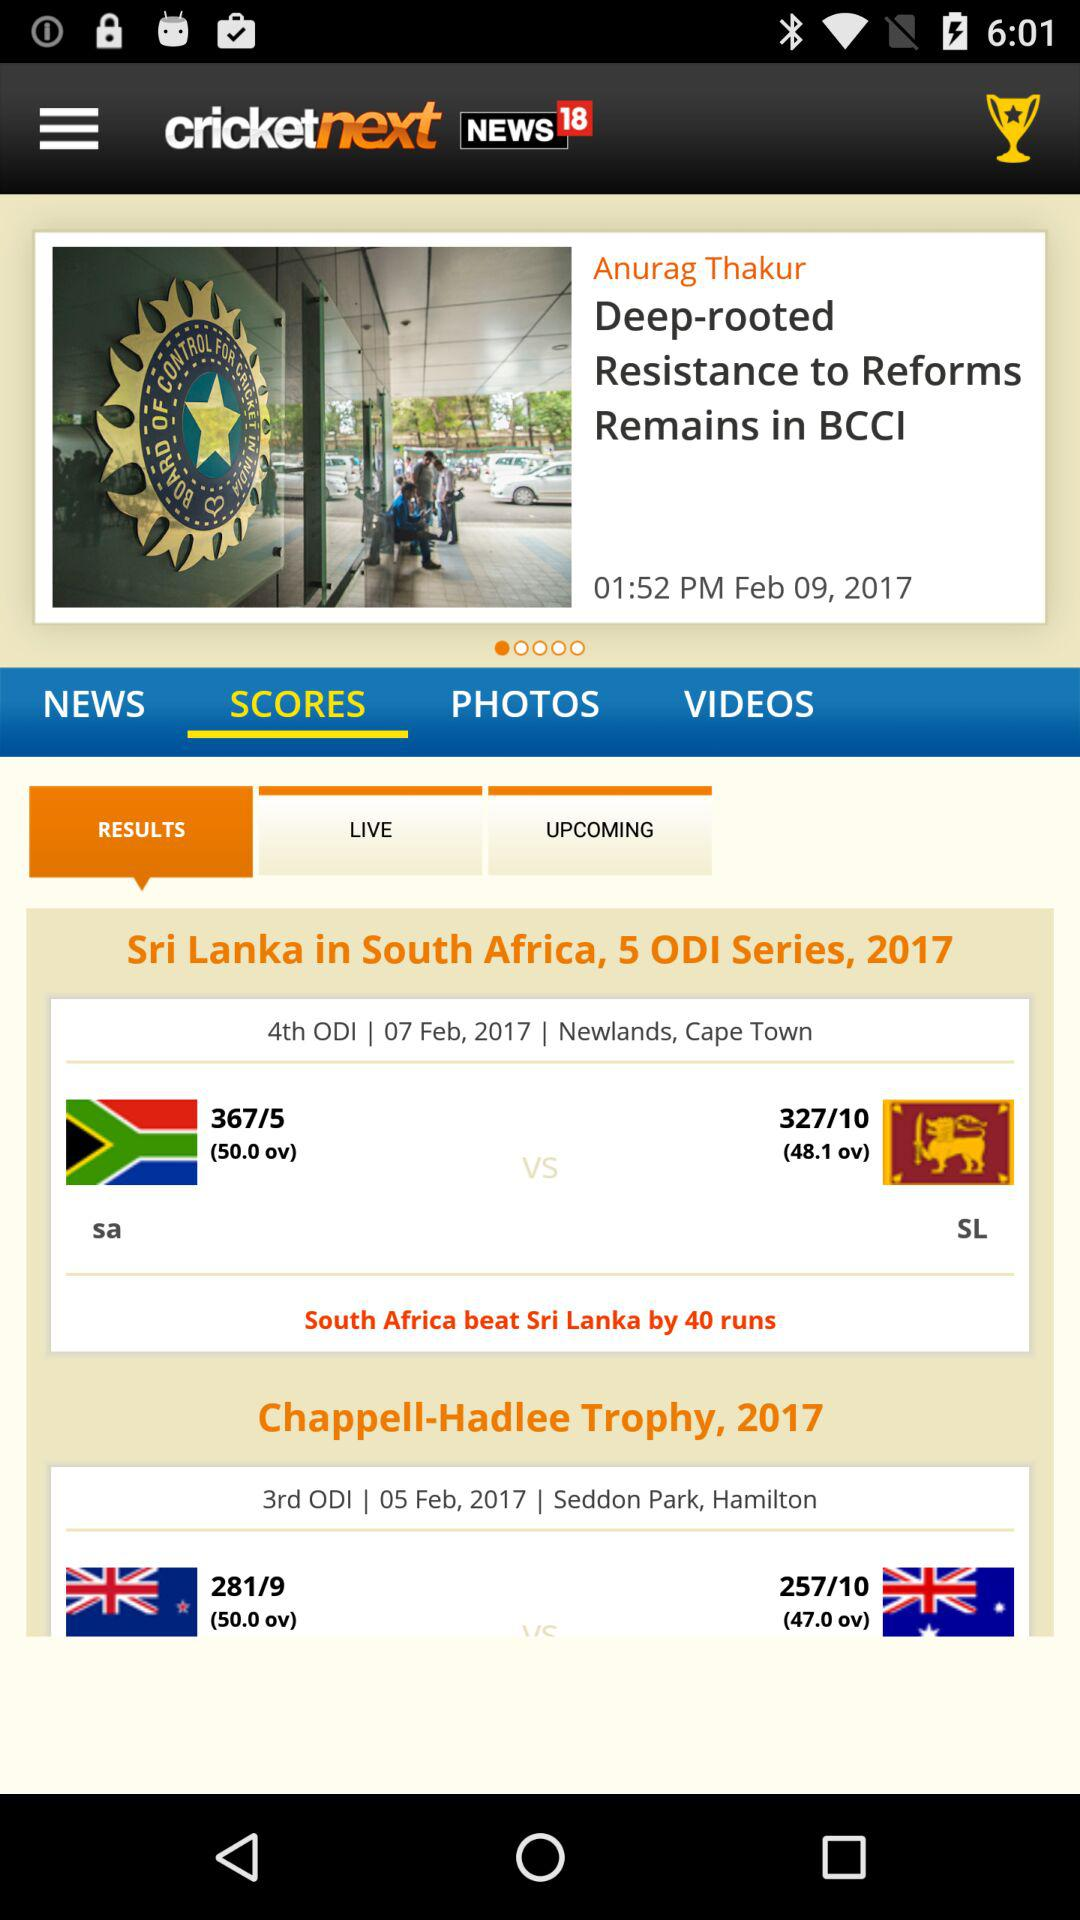What is the application name? The application name is "cricket next". 